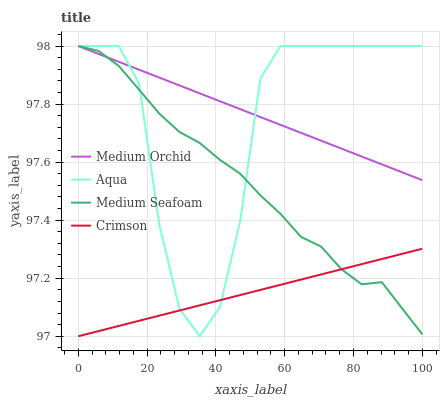Does Crimson have the minimum area under the curve?
Answer yes or no. Yes. Does Medium Orchid have the maximum area under the curve?
Answer yes or no. Yes. Does Aqua have the minimum area under the curve?
Answer yes or no. No. Does Aqua have the maximum area under the curve?
Answer yes or no. No. Is Medium Orchid the smoothest?
Answer yes or no. Yes. Is Aqua the roughest?
Answer yes or no. Yes. Is Aqua the smoothest?
Answer yes or no. No. Is Medium Orchid the roughest?
Answer yes or no. No. Does Aqua have the lowest value?
Answer yes or no. No. Does Medium Seafoam have the highest value?
Answer yes or no. Yes. Is Crimson less than Medium Orchid?
Answer yes or no. Yes. Is Medium Orchid greater than Crimson?
Answer yes or no. Yes. Does Crimson intersect Aqua?
Answer yes or no. Yes. Is Crimson less than Aqua?
Answer yes or no. No. Is Crimson greater than Aqua?
Answer yes or no. No. Does Crimson intersect Medium Orchid?
Answer yes or no. No. 